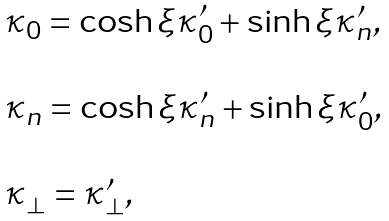Convert formula to latex. <formula><loc_0><loc_0><loc_500><loc_500>\begin{array} { l } \kappa _ { 0 } = \cosh \xi \kappa ^ { \prime } _ { 0 } + \sinh \xi \kappa ^ { \prime } _ { n } , \\ \\ \kappa _ { n } = \cosh \xi \kappa ^ { \prime } _ { n } + \sinh \xi \kappa ^ { \prime } _ { 0 } , \\ \\ \kappa _ { \perp } = \kappa ^ { \prime } _ { \perp } , \end{array}</formula> 